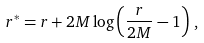Convert formula to latex. <formula><loc_0><loc_0><loc_500><loc_500>r ^ { * } = r + 2 M \log \left ( \frac { r } { 2 M } - 1 \right ) \, ,</formula> 